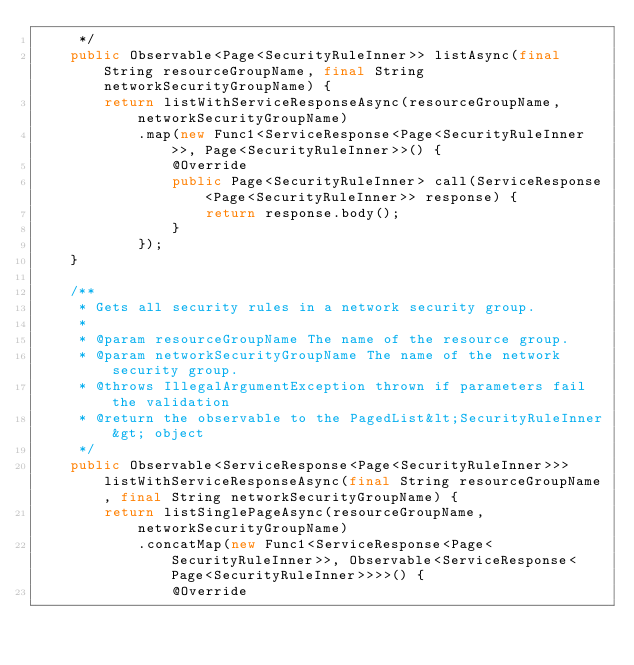Convert code to text. <code><loc_0><loc_0><loc_500><loc_500><_Java_>     */
    public Observable<Page<SecurityRuleInner>> listAsync(final String resourceGroupName, final String networkSecurityGroupName) {
        return listWithServiceResponseAsync(resourceGroupName, networkSecurityGroupName)
            .map(new Func1<ServiceResponse<Page<SecurityRuleInner>>, Page<SecurityRuleInner>>() {
                @Override
                public Page<SecurityRuleInner> call(ServiceResponse<Page<SecurityRuleInner>> response) {
                    return response.body();
                }
            });
    }

    /**
     * Gets all security rules in a network security group.
     *
     * @param resourceGroupName The name of the resource group.
     * @param networkSecurityGroupName The name of the network security group.
     * @throws IllegalArgumentException thrown if parameters fail the validation
     * @return the observable to the PagedList&lt;SecurityRuleInner&gt; object
     */
    public Observable<ServiceResponse<Page<SecurityRuleInner>>> listWithServiceResponseAsync(final String resourceGroupName, final String networkSecurityGroupName) {
        return listSinglePageAsync(resourceGroupName, networkSecurityGroupName)
            .concatMap(new Func1<ServiceResponse<Page<SecurityRuleInner>>, Observable<ServiceResponse<Page<SecurityRuleInner>>>>() {
                @Override</code> 